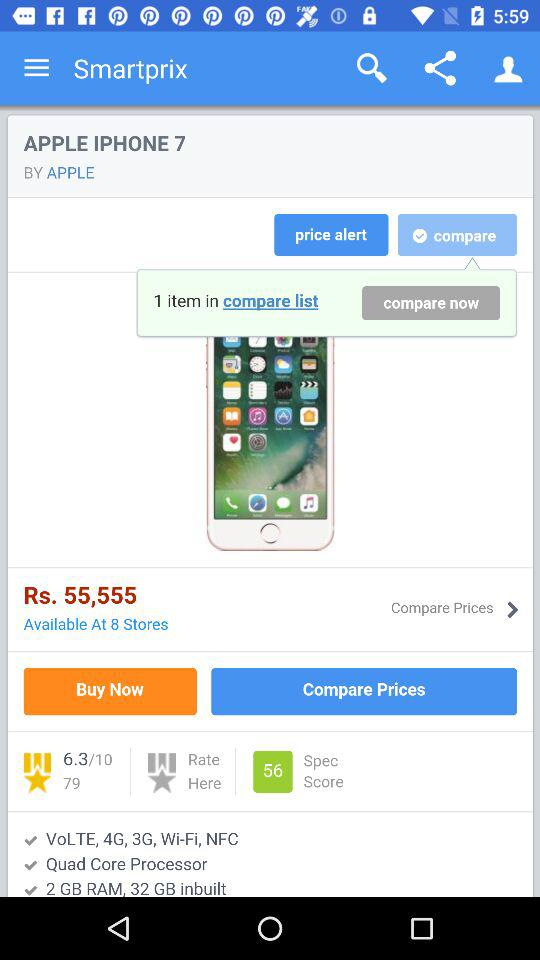What is the price of the Apple iPhone 7? The price of the Apple iPhone 7 is Rs. 55,555. 